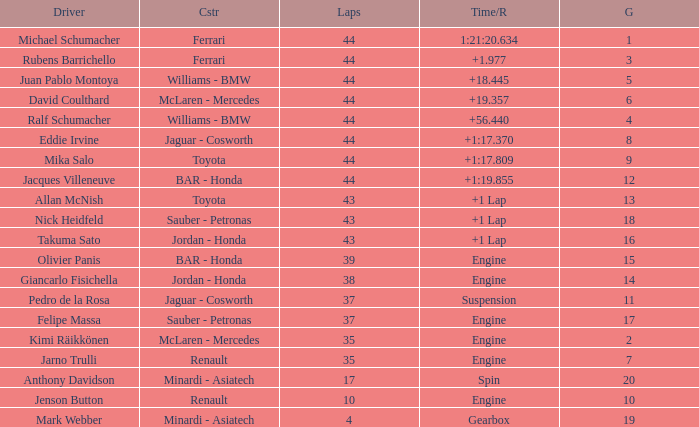What was the fewest laps for somone who finished +18.445? 44.0. 